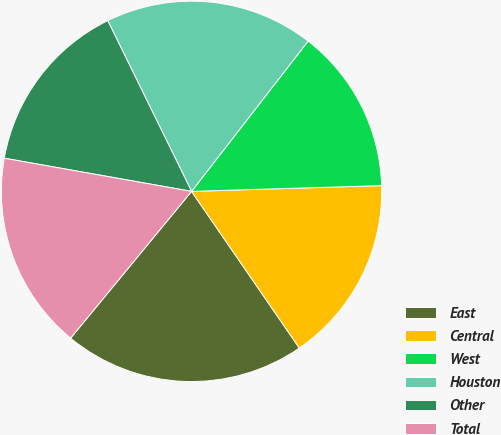Convert chart to OTSL. <chart><loc_0><loc_0><loc_500><loc_500><pie_chart><fcel>East<fcel>Central<fcel>West<fcel>Houston<fcel>Other<fcel>Total<nl><fcel>20.56%<fcel>15.89%<fcel>14.02%<fcel>17.76%<fcel>14.95%<fcel>16.82%<nl></chart> 